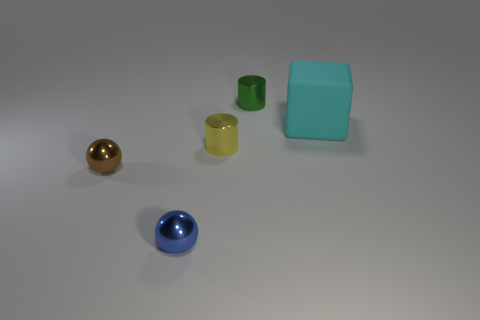Add 4 blue shiny objects. How many objects exist? 9 Subtract all spheres. How many objects are left? 3 Add 2 metal objects. How many metal objects exist? 6 Subtract 1 brown balls. How many objects are left? 4 Subtract all brown things. Subtract all cyan things. How many objects are left? 3 Add 3 small blue balls. How many small blue balls are left? 4 